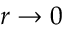<formula> <loc_0><loc_0><loc_500><loc_500>r \rightarrow 0</formula> 